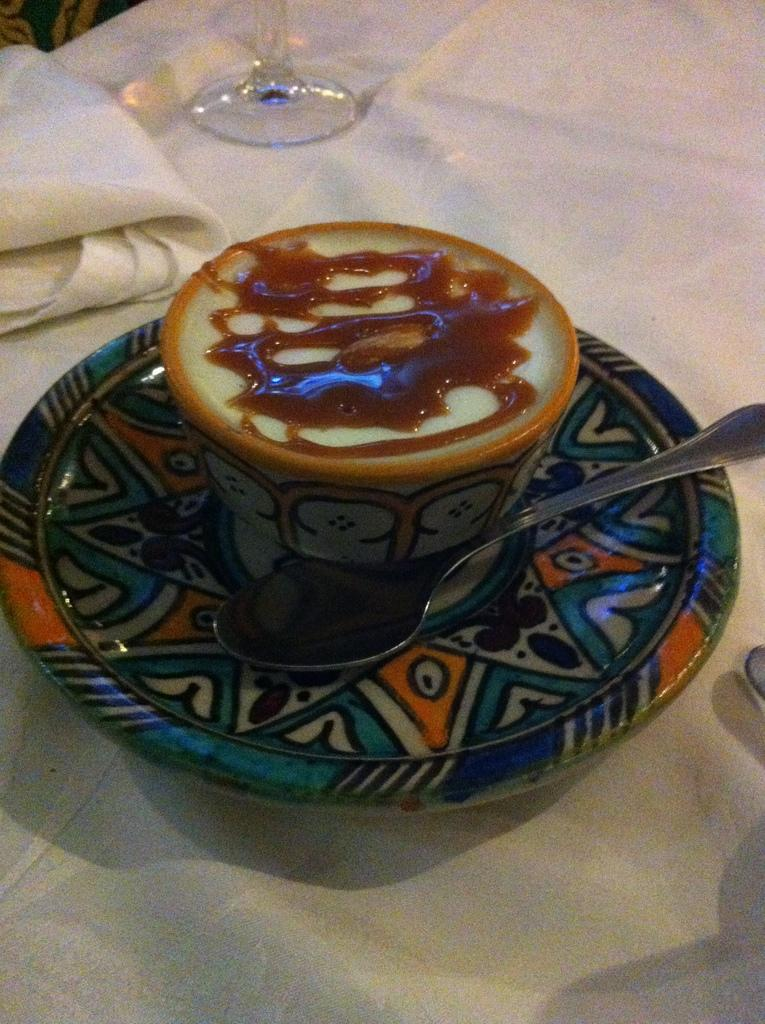What type of furniture is present in the image? There is a table in the image. How is the table decorated or covered? The table is covered with a white cloth. What items are placed on the table? A tea cup, a saucer, a spoon, a cloth, and a glass are placed on the table. What type of destruction is taking place in the image? There is no destruction present in the image; it features a table with various items placed on it. What type of payment is being made in the image? There is no payment being made in the image; it features a table with various items placed on it. 